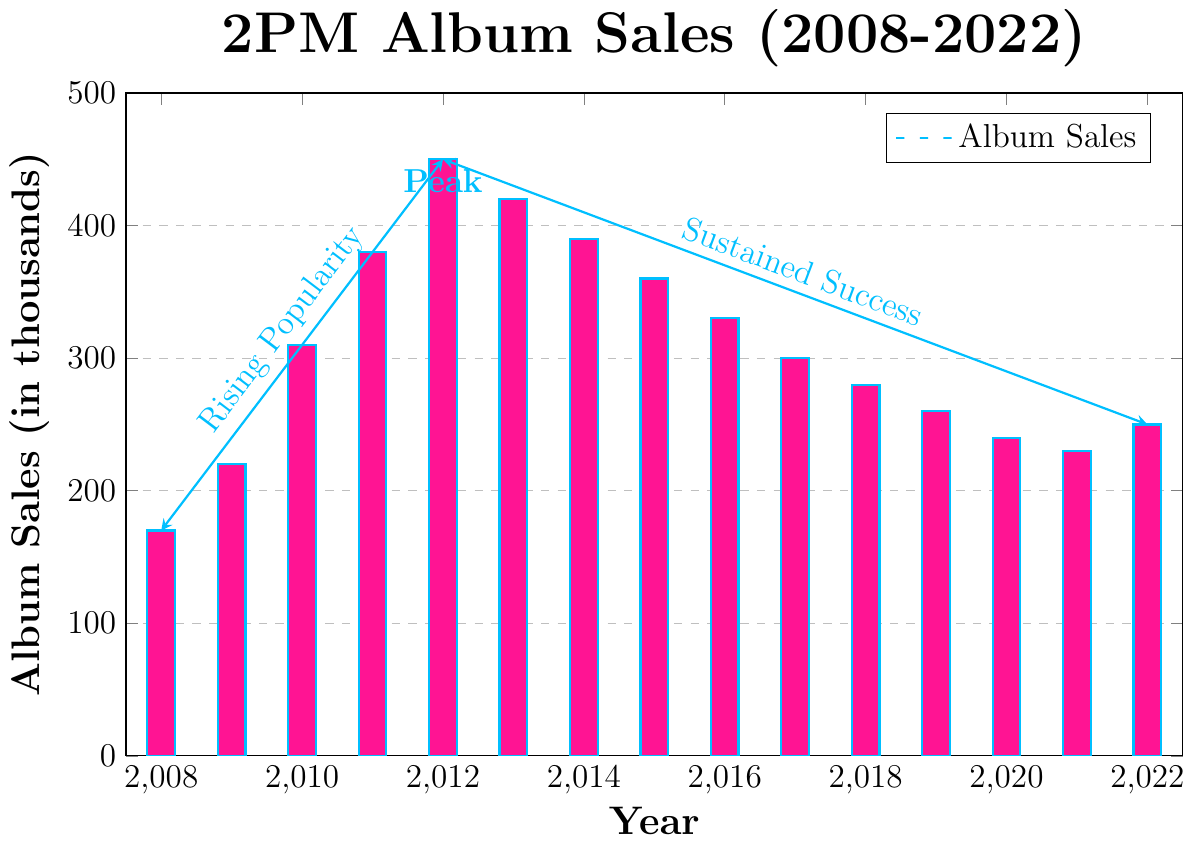When did 2PM reach their peak album sales? According to the chart, 2PM reached their peak album sales in 2012, where the sales were marked with a "Peak" label at 450,000.
Answer: 2012 Which year had the lowest album sales and what was the value? By visually inspecting the bars, 2008 had the shortest bar with the album sales value at 170,000.
Answer: 2008, 170 What is the total number of album sales from 2018 to 2022? Summing up the values from 2018 to 2022: 280 + 260 + 240 + 230 + 250 = 1260. Therefore, the total album sales from 2018 to 2022 are 1260,000.
Answer: 1260 How did the sales trend change from 2008 to 2012? From 2008 to 2012, album sales increased from 170,000 to 450,000. This trend is visually indicated by an upward arrow labeled "Rising Popularity".
Answer: Increased Determine the difference in album sales between the year 2012 and the year 2022. The album sales in 2012 were 450,000 and in 2022 were 250,000. The difference is 450 - 250 = 200 (in thousands).
Answer: 200 Do the years 2013 and 2019 have equal album sales? By comparing the heights of the bars for 2013 and 2019, the album sales for 2013 were 420,000 and for 2019 were 260,000. They are not equal.
Answer: No What is the average album sales from 2010 to 2012? The album sales for 2010, 2011, and 2012 are 310, 380, and 450 (in thousands), respectively. The average is (310 + 380 + 450)/3 = 1140/3 = 380.
Answer: 380 From 2016 to 2022, did album sales increase or decrease? The bar heights from 2016 to 2022 show a downward trend from 330, 300, 280, 260, 240, 230, and 250. The overall trend indicates a decrease.
Answer: Decrease What year marks the transition from rising popularity to sustained success in their sales? The annotation on the chart specifies that the transition occurs around 2012, where there is a change in the trend.
Answer: 2012 Which color is used to fill the bars representing the album sales? The chart visually shows that the bars representing the album sales are filled with pink.
Answer: Pink 